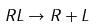Convert formula to latex. <formula><loc_0><loc_0><loc_500><loc_500>R L \rightarrow R + L</formula> 